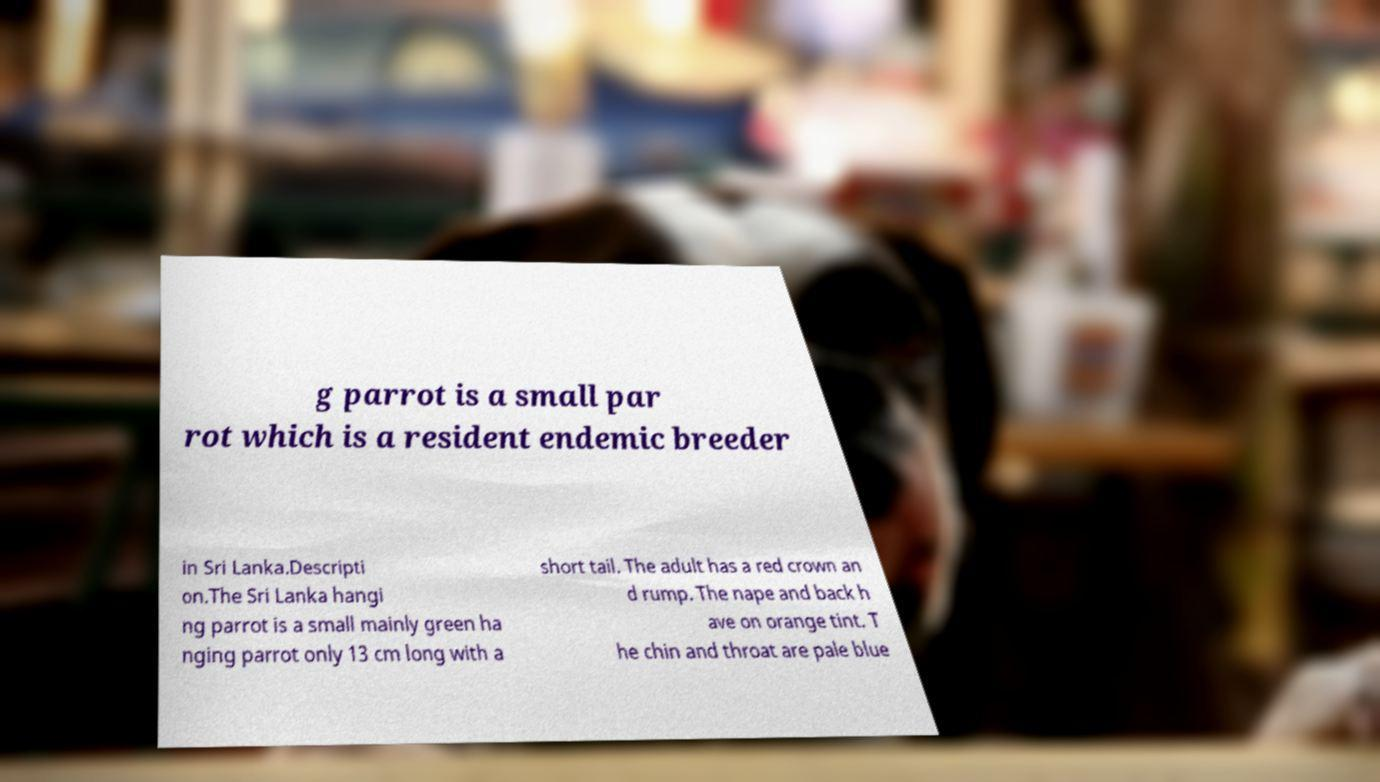Can you read and provide the text displayed in the image?This photo seems to have some interesting text. Can you extract and type it out for me? g parrot is a small par rot which is a resident endemic breeder in Sri Lanka.Descripti on.The Sri Lanka hangi ng parrot is a small mainly green ha nging parrot only 13 cm long with a short tail. The adult has a red crown an d rump. The nape and back h ave on orange tint. T he chin and throat are pale blue 